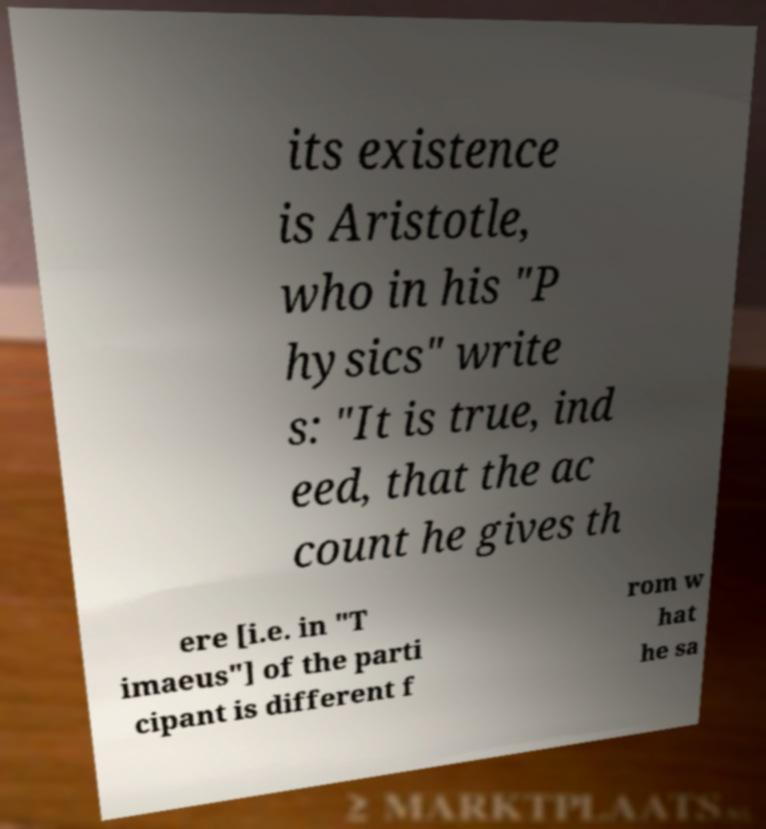For documentation purposes, I need the text within this image transcribed. Could you provide that? its existence is Aristotle, who in his "P hysics" write s: "It is true, ind eed, that the ac count he gives th ere [i.e. in "T imaeus"] of the parti cipant is different f rom w hat he sa 